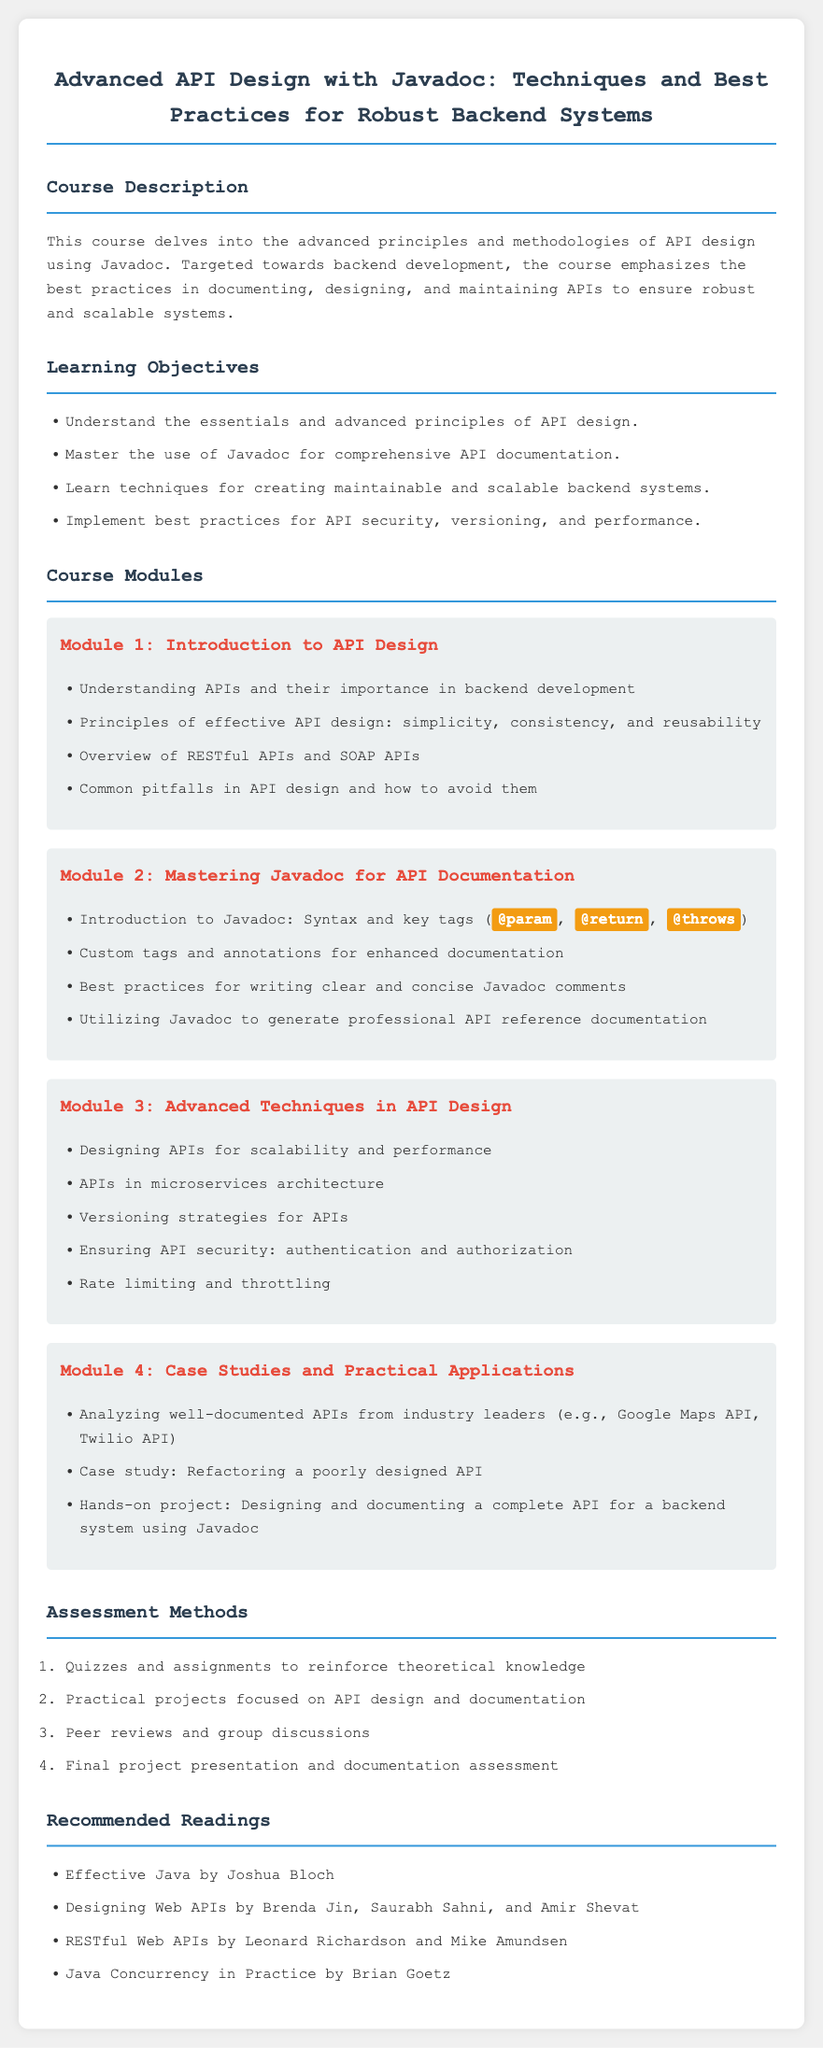What is the title of the course? The title of the course is provided in the header of the syllabus document.
Answer: Advanced API Design with Javadoc: Techniques and Best Practices for Robust Backend Systems What is the first module about? The first module focuses on the fundamental concepts surrounding API design, which is outlined in the syllabus.
Answer: Introduction to API Design How many learning objectives are listed in the syllabus? The number of learning objectives is explicitly stated in the document, listing them in an unordered list.
Answer: Four What type of project is included in Module 4? The project described in Module 4 involves practical application and is specifically mentioned in that module.
Answer: Designing and documenting a complete API for a backend system using Javadoc What is the focus of Module 3? The third module covers advanced techniques in API design as detailed in the syllabus.
Answer: Advanced Techniques in API Design Which book is recommended reading for effective Java programming? The recommended readings include specific books for enhancing knowledge in Java programming, one of which is Effective Java.
Answer: Effective Java by Joshua Bloch What is one of the assessment methods listed? The assessment methods are outlined in an ordered list, detailing various techniques for evaluating students.
Answer: Quizzes and assignments What is emphasized in the course description? The course description provides a focus on principles and methodologies regarding API design specific to a particular area.
Answer: Best practices in documenting, designing, and maintaining APIs 